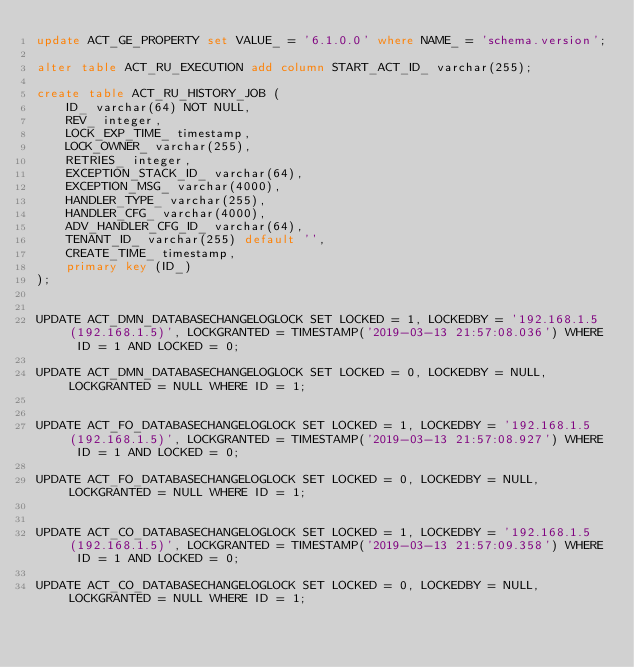Convert code to text. <code><loc_0><loc_0><loc_500><loc_500><_SQL_>update ACT_GE_PROPERTY set VALUE_ = '6.1.0.0' where NAME_ = 'schema.version';

alter table ACT_RU_EXECUTION add column START_ACT_ID_ varchar(255);

create table ACT_RU_HISTORY_JOB (
    ID_ varchar(64) NOT NULL,
    REV_ integer,
    LOCK_EXP_TIME_ timestamp,
    LOCK_OWNER_ varchar(255),
    RETRIES_ integer,
    EXCEPTION_STACK_ID_ varchar(64),
    EXCEPTION_MSG_ varchar(4000),
    HANDLER_TYPE_ varchar(255),
    HANDLER_CFG_ varchar(4000),
    ADV_HANDLER_CFG_ID_ varchar(64),
    TENANT_ID_ varchar(255) default '',
    CREATE_TIME_ timestamp,
    primary key (ID_)
);


UPDATE ACT_DMN_DATABASECHANGELOGLOCK SET LOCKED = 1, LOCKEDBY = '192.168.1.5 (192.168.1.5)', LOCKGRANTED = TIMESTAMP('2019-03-13 21:57:08.036') WHERE ID = 1 AND LOCKED = 0;

UPDATE ACT_DMN_DATABASECHANGELOGLOCK SET LOCKED = 0, LOCKEDBY = NULL, LOCKGRANTED = NULL WHERE ID = 1;


UPDATE ACT_FO_DATABASECHANGELOGLOCK SET LOCKED = 1, LOCKEDBY = '192.168.1.5 (192.168.1.5)', LOCKGRANTED = TIMESTAMP('2019-03-13 21:57:08.927') WHERE ID = 1 AND LOCKED = 0;

UPDATE ACT_FO_DATABASECHANGELOGLOCK SET LOCKED = 0, LOCKEDBY = NULL, LOCKGRANTED = NULL WHERE ID = 1;


UPDATE ACT_CO_DATABASECHANGELOGLOCK SET LOCKED = 1, LOCKEDBY = '192.168.1.5 (192.168.1.5)', LOCKGRANTED = TIMESTAMP('2019-03-13 21:57:09.358') WHERE ID = 1 AND LOCKED = 0;

UPDATE ACT_CO_DATABASECHANGELOGLOCK SET LOCKED = 0, LOCKEDBY = NULL, LOCKGRANTED = NULL WHERE ID = 1;

</code> 